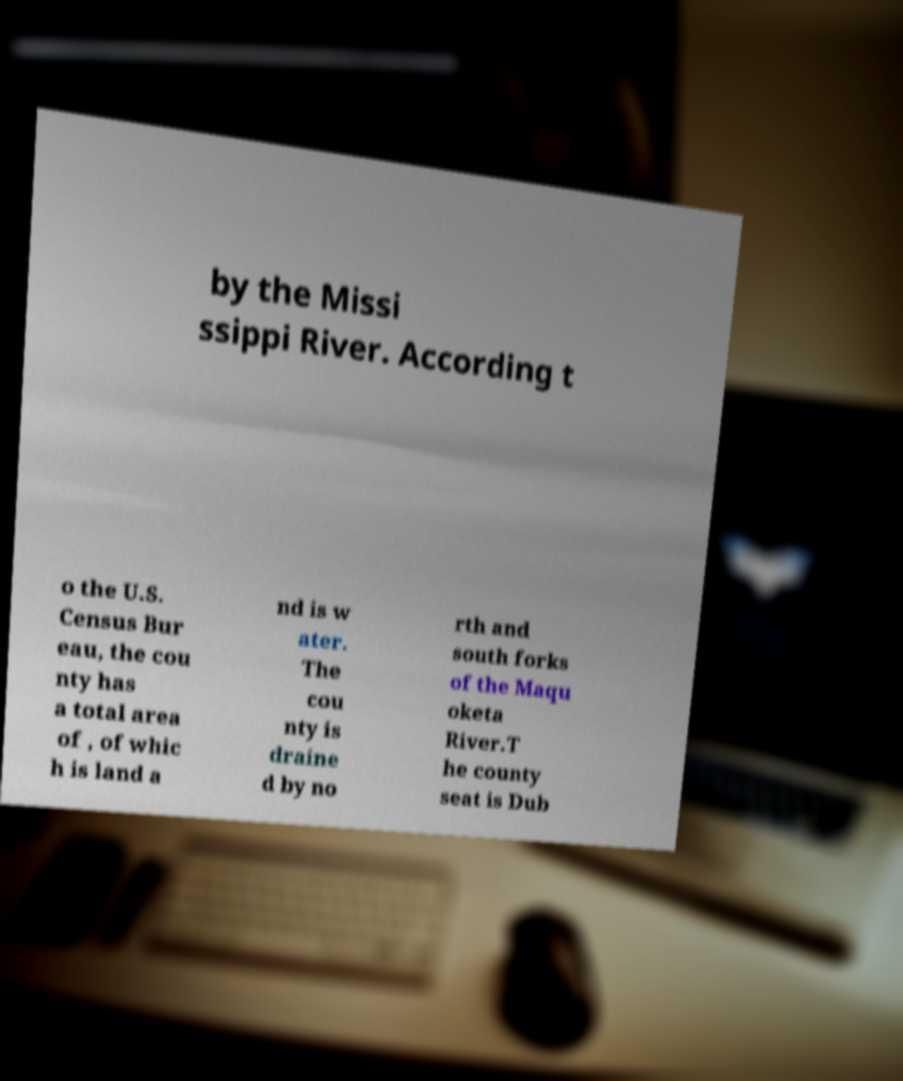What messages or text are displayed in this image? I need them in a readable, typed format. by the Missi ssippi River. According t o the U.S. Census Bur eau, the cou nty has a total area of , of whic h is land a nd is w ater. The cou nty is draine d by no rth and south forks of the Maqu oketa River.T he county seat is Dub 